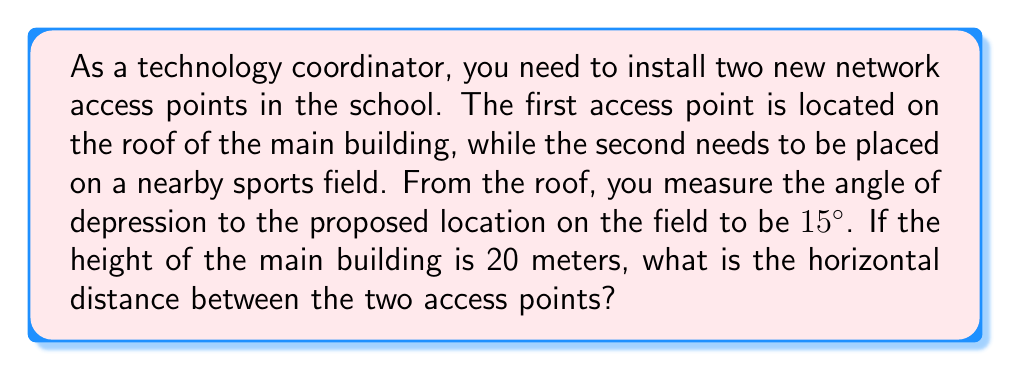Could you help me with this problem? Let's approach this step-by-step using trigonometry:

1) First, let's visualize the problem:

[asy]
import geometry;

size(200);
pair A = (0,0), B = (200,0), C = (0,60);
draw(A--B--C--A);
draw(C--(-20,0), dashed);
label("20m", C--(-20,0), W);
label("θ = 15°", (10,50), E);
label("x", (100,-10), S);
label("A", C, N);
label("B", B, SE);

draw(arc(C,20,270,285), arrow=Arrow(TeXHead));
[/asy]

2) In this right-angled triangle:
   - The vertical side is the height of the building (20 meters)
   - The angle of depression is 15°
   - We need to find the horizontal distance (let's call it x)

3) The tangent function relates the opposite and adjacent sides in a right triangle:

   $$\tan \theta = \frac{\text{opposite}}{\text{adjacent}}$$

4) In our case:

   $$\tan 15° = \frac{20}{x}$$

5) To solve for x, we can rearrange the equation:

   $$x = \frac{20}{\tan 15°}$$

6) Now, let's calculate:

   $$x = \frac{20}{\tan 15°} \approx 74.55 \text{ meters}$$

Therefore, the horizontal distance between the two access points is approximately 74.55 meters.
Answer: 74.55 meters 